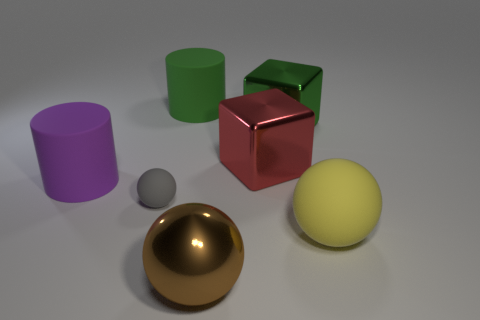Subtract all large brown spheres. How many spheres are left? 2 Subtract all red blocks. How many blocks are left? 1 Subtract 1 balls. How many balls are left? 2 Subtract all blocks. How many objects are left? 5 Subtract all cyan cubes. How many cyan spheres are left? 0 Add 3 spheres. How many objects exist? 10 Add 3 metal balls. How many metal balls are left? 4 Add 7 large spheres. How many large spheres exist? 9 Subtract 1 green cylinders. How many objects are left? 6 Subtract all purple blocks. Subtract all red cylinders. How many blocks are left? 2 